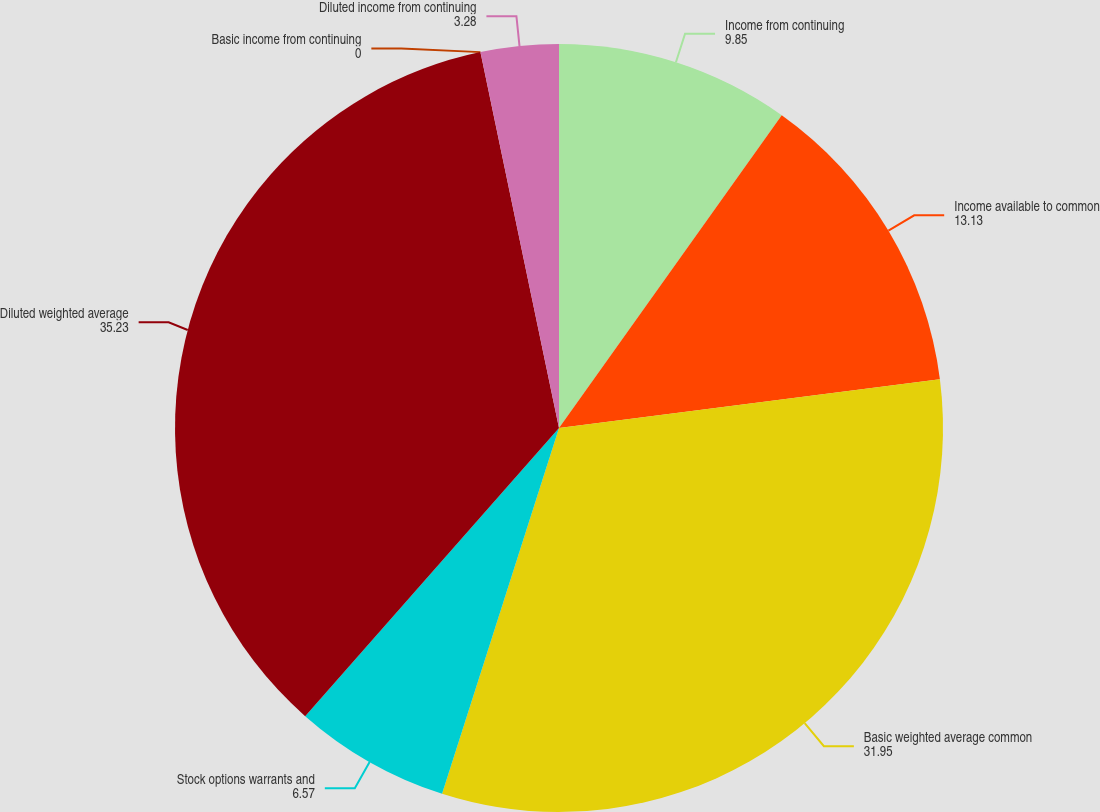Convert chart. <chart><loc_0><loc_0><loc_500><loc_500><pie_chart><fcel>Income from continuing<fcel>Income available to common<fcel>Basic weighted average common<fcel>Stock options warrants and<fcel>Diluted weighted average<fcel>Basic income from continuing<fcel>Diluted income from continuing<nl><fcel>9.85%<fcel>13.13%<fcel>31.95%<fcel>6.57%<fcel>35.23%<fcel>0.0%<fcel>3.28%<nl></chart> 